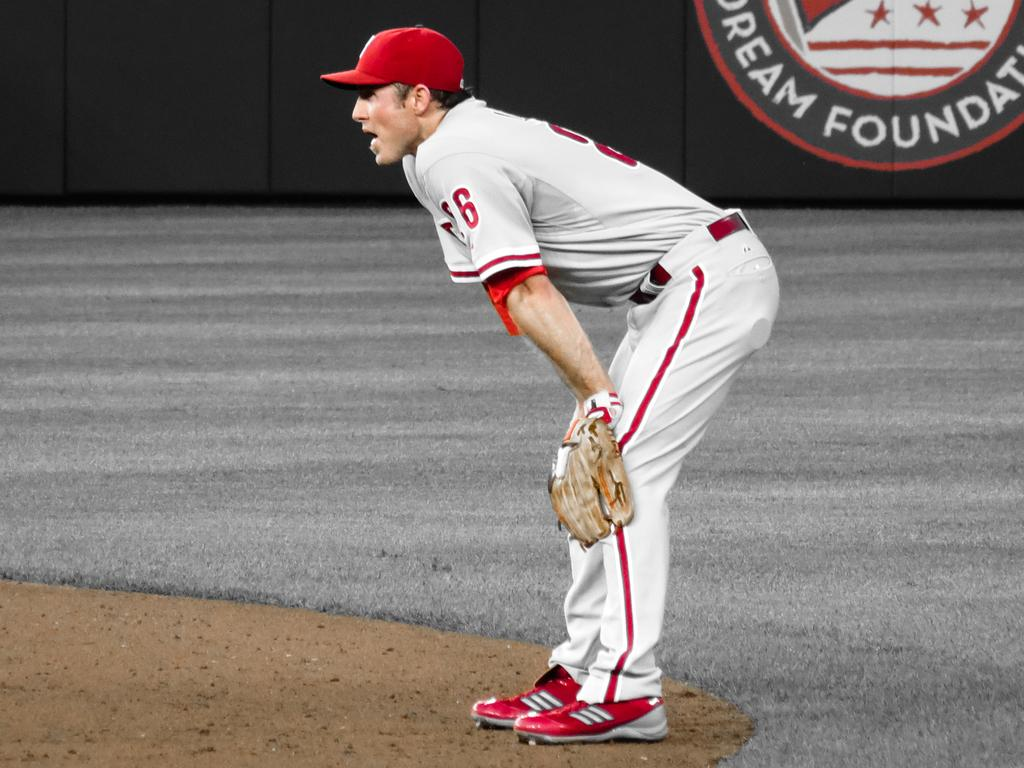<image>
Summarize the visual content of the image. A baseball player stands on a field sponsored by Dream Foundation. 